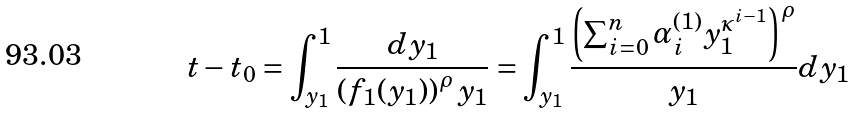<formula> <loc_0><loc_0><loc_500><loc_500>t - t _ { 0 } = \int _ { y _ { 1 } } ^ { 1 } \frac { d y _ { 1 } } { \left ( f _ { 1 } ( y _ { 1 } ) \right ) ^ { \rho } y _ { 1 } } = \int _ { y _ { 1 } } ^ { 1 } \frac { \left ( \sum _ { i = 0 } ^ { n } \alpha _ { i } ^ { ( 1 ) } y _ { 1 } ^ { \kappa ^ { i - 1 } } \right ) ^ { \rho } } { y _ { 1 } } d y _ { 1 }</formula> 